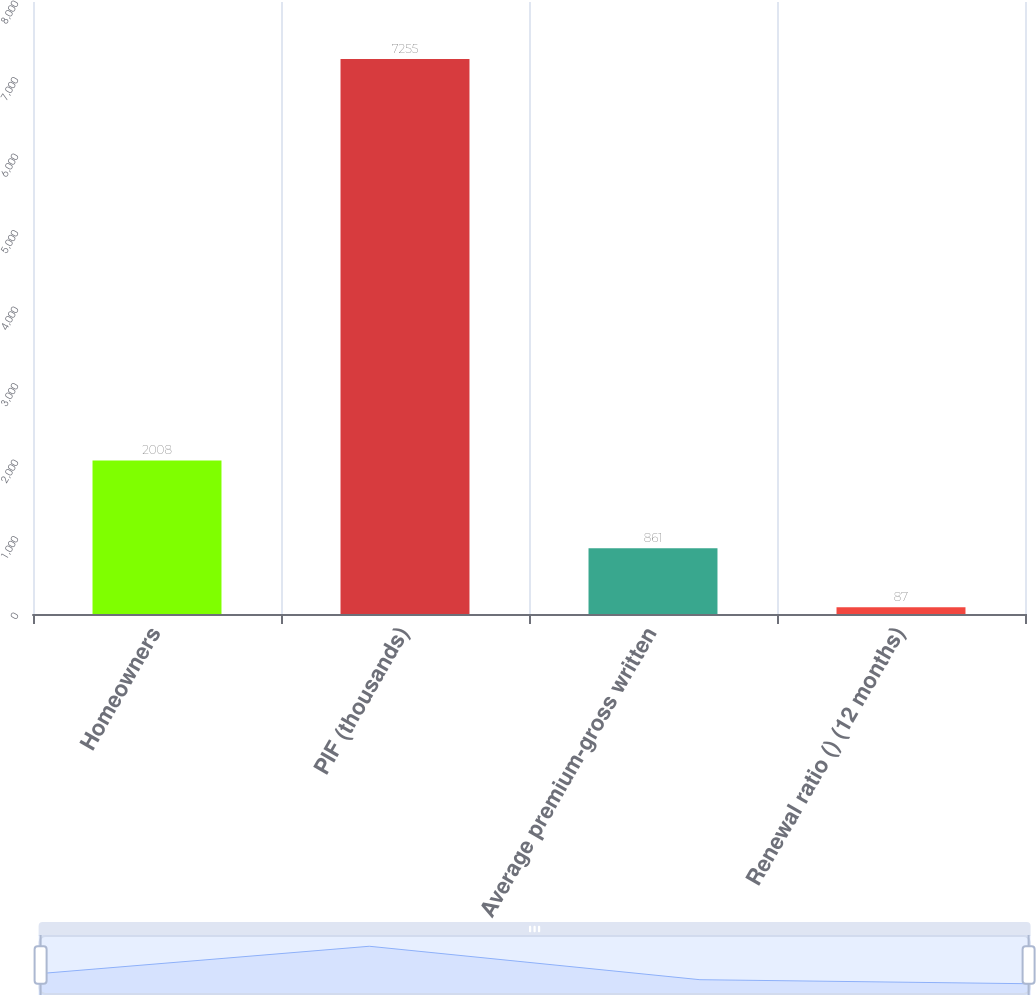Convert chart to OTSL. <chart><loc_0><loc_0><loc_500><loc_500><bar_chart><fcel>Homeowners<fcel>PIF (thousands)<fcel>Average premium-gross written<fcel>Renewal ratio () (12 months)<nl><fcel>2008<fcel>7255<fcel>861<fcel>87<nl></chart> 